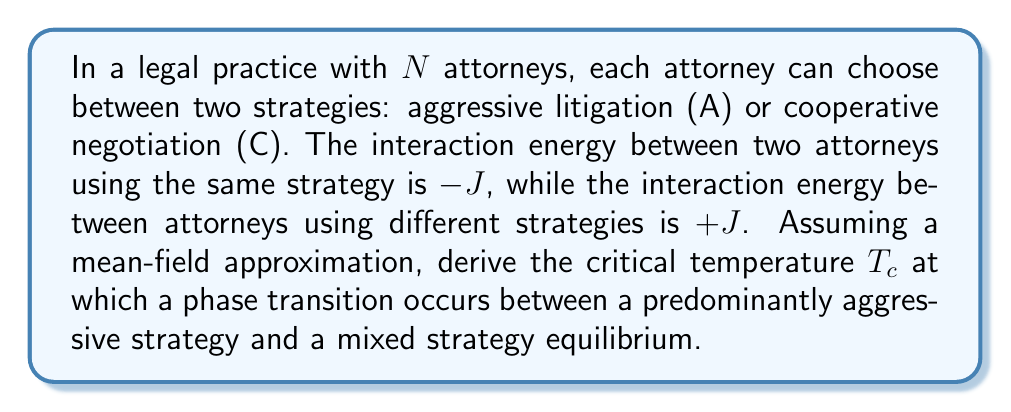Show me your answer to this math problem. 1. Define the order parameter $m$ as the difference between the fraction of attorneys using strategy A and C:
   $$ m = \frac{N_A - N_C}{N} $$

2. In the mean-field approximation, the energy of the system can be written as:
   $$ E = -\frac{1}{2}JN(1+m^2) $$

3. The free energy per attorney in the mean-field approximation is:
   $$ f = -\frac{1}{2}J(1+m^2) - T\left[-\frac{1+m}{2}\ln\left(\frac{1+m}{2}\right) - \frac{1-m}{2}\ln\left(\frac{1-m}{2}\right)\right] $$

4. At equilibrium, we minimize the free energy with respect to $m$:
   $$ \frac{\partial f}{\partial m} = -Jm - T\left[\frac{1}{2}\ln\left(\frac{1+m}{1-m}\right)\right] = 0 $$

5. This leads to the self-consistent equation:
   $$ m = \tanh\left(\frac{Jm}{T}\right) $$

6. Near the critical temperature, $m$ is small, so we can expand $\tanh(x) \approx x - \frac{1}{3}x^3$:
   $$ m \approx \frac{Jm}{T} - \frac{1}{3}\left(\frac{Jm}{T}\right)^3 $$

7. Rearranging terms:
   $$ m\left(1 - \frac{J}{T}\right) \approx -\frac{1}{3}\frac{J^3m^3}{T^3} $$

8. For a non-trivial solution ($m \neq 0$), we must have:
   $$ 1 - \frac{J}{T} = 0 $$

9. Solving for $T$, we find the critical temperature:
   $$ T_c = J $$
Answer: $T_c = J$ 